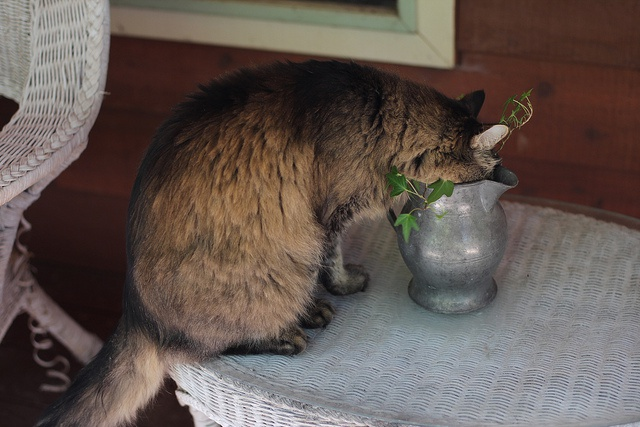Describe the objects in this image and their specific colors. I can see cat in gray, black, and maroon tones, chair in gray, darkgray, and black tones, potted plant in gray, black, and maroon tones, and vase in gray, black, and purple tones in this image. 